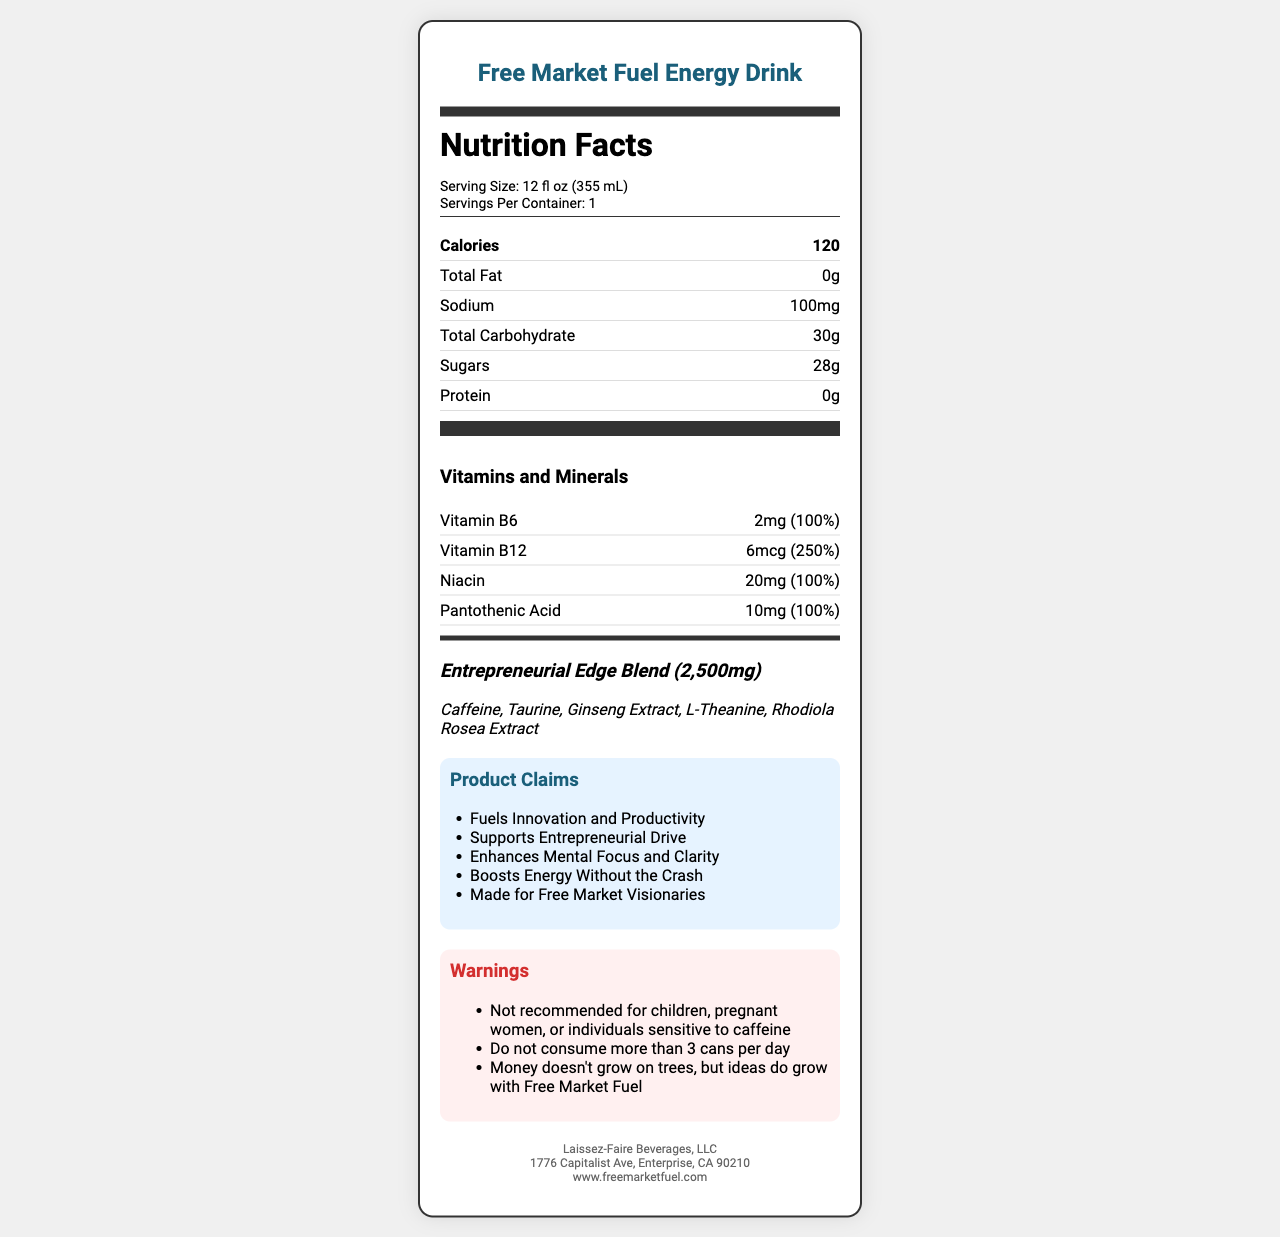what is the product name? The product name is prominently displayed at the top of the document.
Answer: Free Market Fuel Energy Drink what is the serving size? The serving size is specified at the top of the nutrition facts section.
Answer: 12 fl oz (355 mL) how many calories are in one serving? The calories per serving are listed right below the serving information.
Answer: 120 what is the total amount of sugars per serving? The total sugars content is listed under the carbohydrates section.
Answer: 28g how much Vitamin B12 is in the drink, and what percentage of the daily value does it represent? The vitamin and its daily value percentage are listed in the vitamins and minerals section.
Answer: 6mcg, 250% list the ingredients in the Entrepreneurial Edge Blend The ingredients of the proprietary blend are detailed in the blend section.
Answer: Caffeine, Taurine, Ginseng Extract, L-Theanine, Rhodiola Rosea Extract what are the marketing claims made by this energy drink? The marketing claims are listed in the product claims section.
Answer: Fuels Innovation and Productivity, Supports Entrepreneurial Drive, Enhances Mental Focus and Clarity, Boosts Energy Without the Crash, Made for Free Market Visionaries does the drink contain any protein? The document specifies that the protein content is 0g.
Answer: No list the preservatives used in the drink The preservatives are listed in the other ingredients section.
Answer: Potassium Benzoate, Potassium Sorbate which company produces this energy drink? A. Capitalist Enterprises B. Free Market Fuel Inc. C. Laissez-Faire Beverages, LLC D. Innovation Drinks Inc. The company information at the bottom of the document specifies the company as Laissez-Faire Beverages, LLC.
Answer: C how many servings are there per container? A. 1 B. 2 C. 3 D. 4 The servings per container are listed in the serving information section.
Answer: A is there any recommendation regarding the maximum consumption per day? The warnings section indicates that no more than 3 cans should be consumed per day.
Answer: Yes is this drink recommended for children? The warnings section explicitly states that it is not recommended for children.
Answer: No summarize the main purpose of this energy drink according to the document The document provides detailed information about the drink's nutritional content, proprietary blend, marketing claims, and warnings, all emphasizing innovation and productivity.
Answer: The Free Market Fuel Energy Drink is designed to fuel innovation and productivity, support entrepreneurial drive, enhance mental focus and clarity, and boost energy without causing a crash. It contains a proprietary blend of productivity-boosting nutrients and is marketed towards free market visionaries. what is the exact quantity of citric acid in the drink? The document lists citric acid as an ingredient but does not specify its quantity.
Answer: Not enough information 